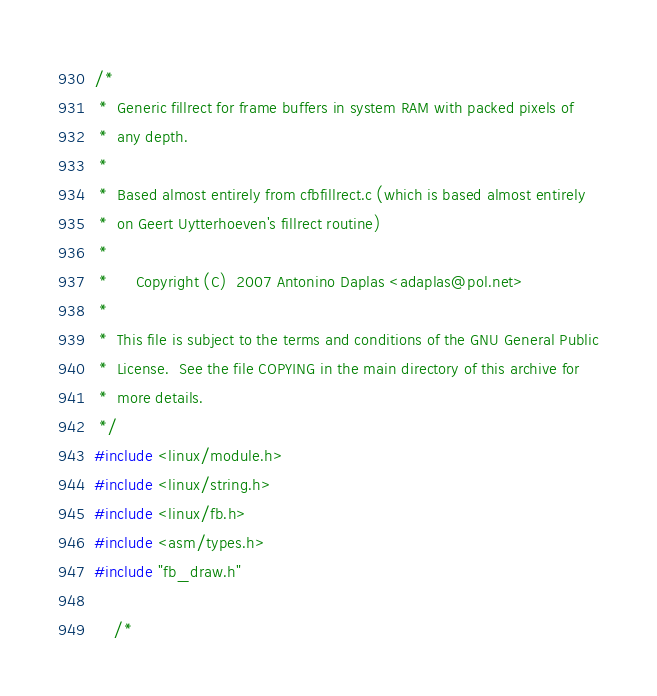<code> <loc_0><loc_0><loc_500><loc_500><_C_>/*
 *  Generic fillrect for frame buffers in system RAM with packed pixels of
 *  any depth.
 *
 *  Based almost entirely from cfbfillrect.c (which is based almost entirely
 *  on Geert Uytterhoeven's fillrect routine)
 *
 *      Copyright (C)  2007 Antonino Daplas <adaplas@pol.net>
 *
 *  This file is subject to the terms and conditions of the GNU General Public
 *  License.  See the file COPYING in the main directory of this archive for
 *  more details.
 */
#include <linux/module.h>
#include <linux/string.h>
#include <linux/fb.h>
#include <asm/types.h>
#include "fb_draw.h"

    /*</code> 